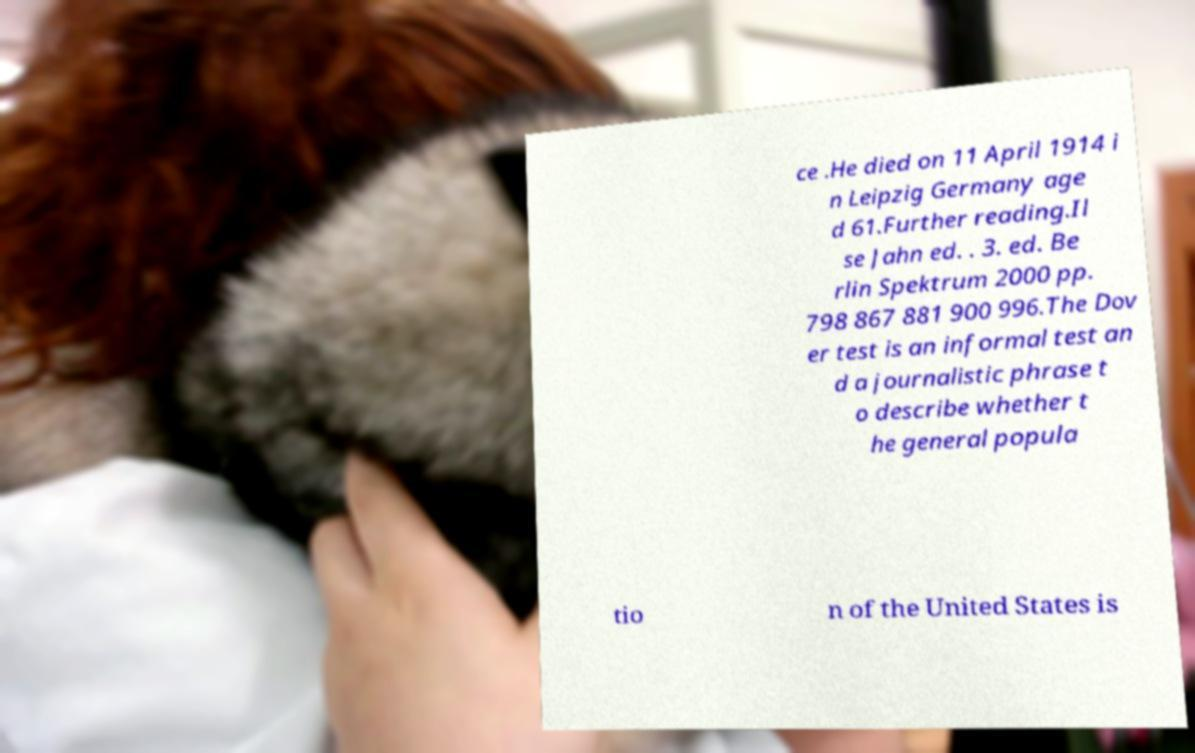For documentation purposes, I need the text within this image transcribed. Could you provide that? ce .He died on 11 April 1914 i n Leipzig Germany age d 61.Further reading.Il se Jahn ed. . 3. ed. Be rlin Spektrum 2000 pp. 798 867 881 900 996.The Dov er test is an informal test an d a journalistic phrase t o describe whether t he general popula tio n of the United States is 